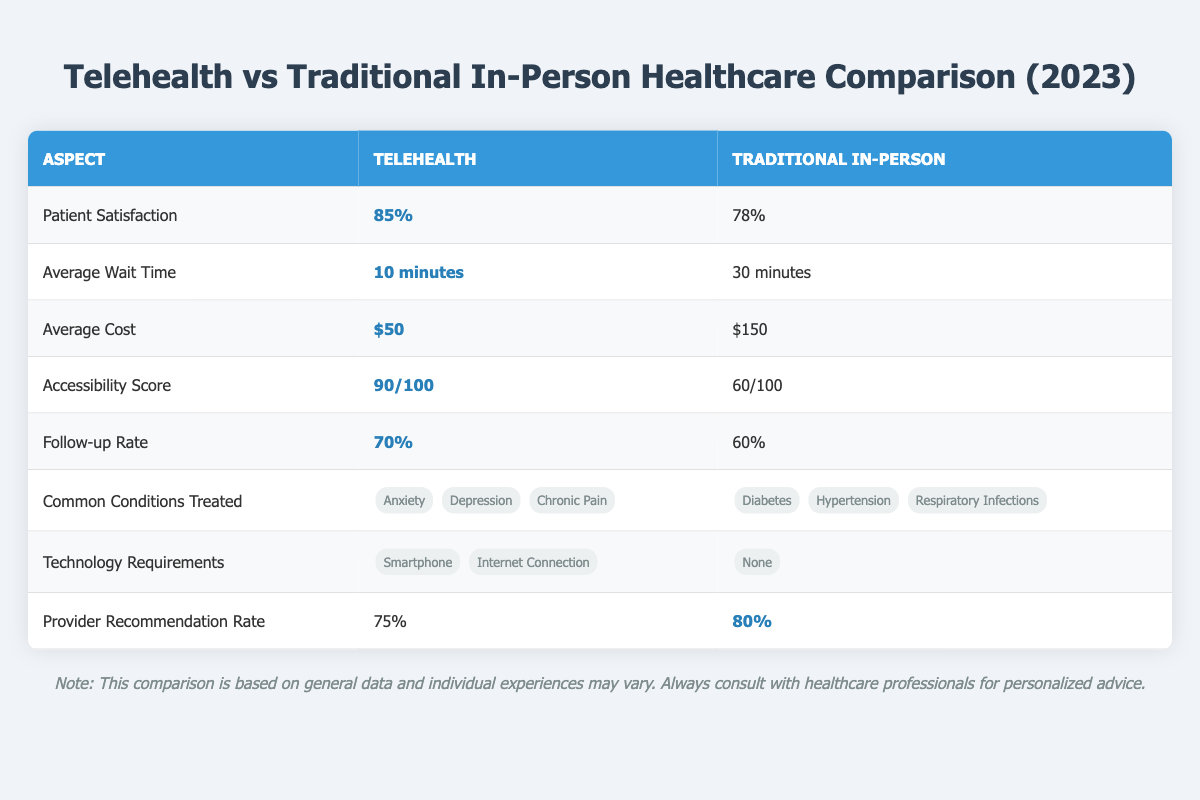What is the patient satisfaction percentage for telehealth services? The table indicates that the patient satisfaction percentage for telehealth services is listed as 85%.
Answer: 85% What is the average wait time for traditional in-person visits? According to the table, the average wait time for traditional in-person visits is 30 minutes.
Answer: 30 minutes How much does a telehealth visit cost on average? The average cost for a telehealth visit is shown as $50 in the table.
Answer: $50 What is the accessibility score for telehealth services? The accessibility score for telehealth services is listed as 90 out of 100 in the table.
Answer: 90/100 Which service type has a higher follow-up rate? The table indicates that telehealth has a follow-up rate of 70% while traditional in-person visits have a follow-up rate of 60%, meaning telehealth has a higher follow-up rate.
Answer: Telehealth What are the common conditions treated by traditional in-person visits? The table lists common conditions treated by traditional in-person visits as diabetes, hypertension, and respiratory infections.
Answer: Diabetes, Hypertension, Respiratory Infections What are the technology requirements for telehealth services? The table specifies that the technology requirements for telehealth services are a smartphone and an internet connection.
Answer: Smartphone, Internet Connection What is the difference in average cost between telehealth and traditional in-person visits? The average cost for telehealth is $50, and for traditional in-person visits, it is $150. The difference is $150 - $50 = $100.
Answer: $100 Is the provider recommendation rate higher for telehealth or traditional in-person visits? The table shows that the provider recommendation rate for telehealth is 75%, while for traditional in-person visits, it is 80%. Therefore, traditional in-person visits have a higher recommendation rate.
Answer: Traditional In-Person How many more minutes do patients typically wait for traditional in-person visits compared to telehealth visits? The average wait time for traditional in-person visits is 30 minutes, while for telehealth, it is 10 minutes. The difference is 30 - 10 = 20 minutes.
Answer: 20 minutes Would you recommend telehealth services based on patient satisfaction rates? Based on the table, telehealth services have a higher patient satisfaction percentage (85%) compared to traditional in-person (78%), suggesting it could be recommended.
Answer: Yes 